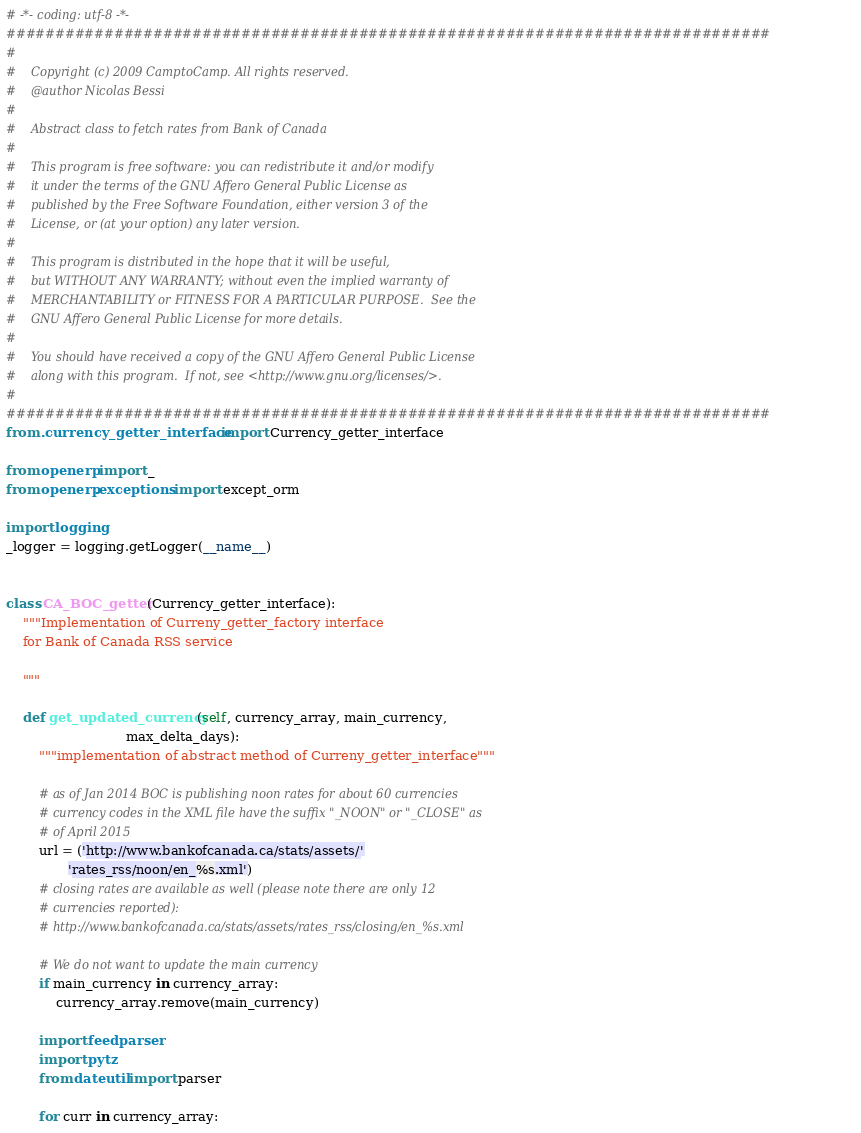<code> <loc_0><loc_0><loc_500><loc_500><_Python_># -*- coding: utf-8 -*-
##############################################################################
#
#    Copyright (c) 2009 CamptoCamp. All rights reserved.
#    @author Nicolas Bessi
#
#    Abstract class to fetch rates from Bank of Canada
#
#    This program is free software: you can redistribute it and/or modify
#    it under the terms of the GNU Affero General Public License as
#    published by the Free Software Foundation, either version 3 of the
#    License, or (at your option) any later version.
#
#    This program is distributed in the hope that it will be useful,
#    but WITHOUT ANY WARRANTY; without even the implied warranty of
#    MERCHANTABILITY or FITNESS FOR A PARTICULAR PURPOSE.  See the
#    GNU Affero General Public License for more details.
#
#    You should have received a copy of the GNU Affero General Public License
#    along with this program.  If not, see <http://www.gnu.org/licenses/>.
#
##############################################################################
from .currency_getter_interface import Currency_getter_interface

from openerp import _
from openerp.exceptions import except_orm

import logging
_logger = logging.getLogger(__name__)


class CA_BOC_getter(Currency_getter_interface):
    """Implementation of Curreny_getter_factory interface
    for Bank of Canada RSS service

    """

    def get_updated_currency(self, currency_array, main_currency,
                             max_delta_days):
        """implementation of abstract method of Curreny_getter_interface"""

        # as of Jan 2014 BOC is publishing noon rates for about 60 currencies
        # currency codes in the XML file have the suffix "_NOON" or "_CLOSE" as
        # of April 2015
        url = ('http://www.bankofcanada.ca/stats/assets/'
               'rates_rss/noon/en_%s.xml')
        # closing rates are available as well (please note there are only 12
        # currencies reported):
        # http://www.bankofcanada.ca/stats/assets/rates_rss/closing/en_%s.xml

        # We do not want to update the main currency
        if main_currency in currency_array:
            currency_array.remove(main_currency)

        import feedparser
        import pytz
        from dateutil import parser

        for curr in currency_array:
</code> 